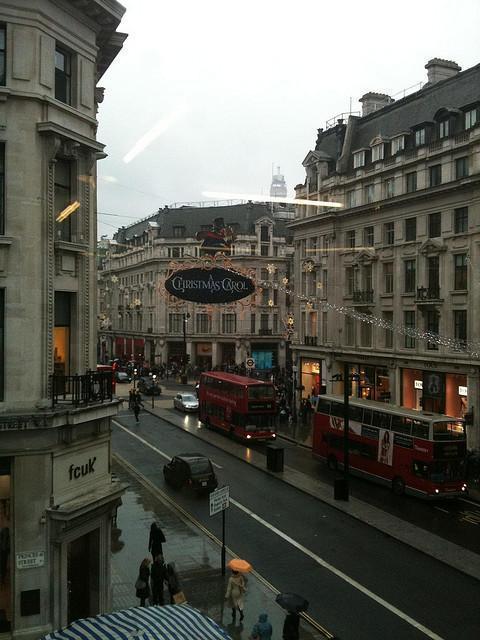Why is the woman carrying an orange umbrella?
Select the accurate response from the four choices given to answer the question.
Options: It's raining, showing off, it's sunny, for fashion. It's raining. 